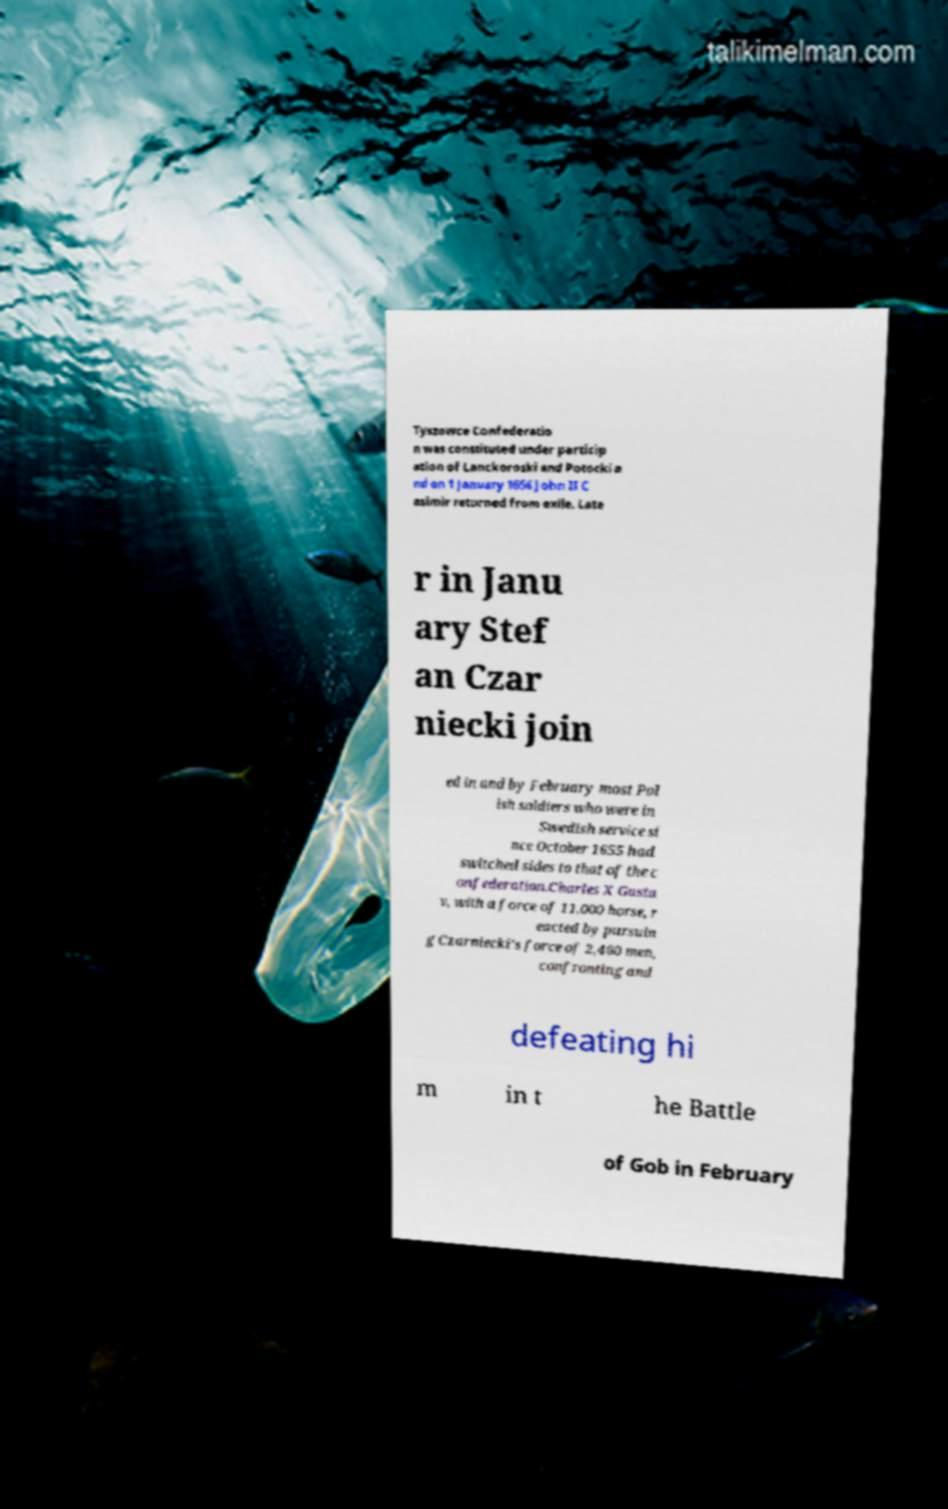What messages or text are displayed in this image? I need them in a readable, typed format. Tyszowce Confederatio n was constituted under particip ation of Lanckoroski and Potocki a nd on 1 January 1656 John II C asimir returned from exile. Late r in Janu ary Stef an Czar niecki join ed in and by February most Pol ish soldiers who were in Swedish service si nce October 1655 had switched sides to that of the c onfederation.Charles X Gusta v, with a force of 11,000 horse, r eacted by pursuin g Czarniecki's force of 2,400 men, confronting and defeating hi m in t he Battle of Gob in February 